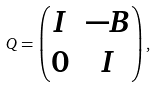<formula> <loc_0><loc_0><loc_500><loc_500>Q = \begin{pmatrix} I & - B \\ 0 & I \end{pmatrix} ,</formula> 